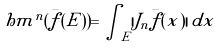Convert formula to latex. <formula><loc_0><loc_0><loc_500><loc_500>\ h m ^ { n } ( \bar { f } ( E ) ) = \int _ { E } | J _ { n } \bar { f } ( x ) | \, d x</formula> 